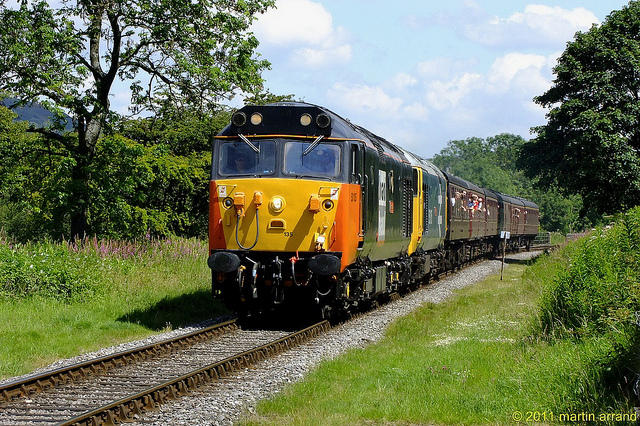Read all the text in this image. arrand martin 2011 